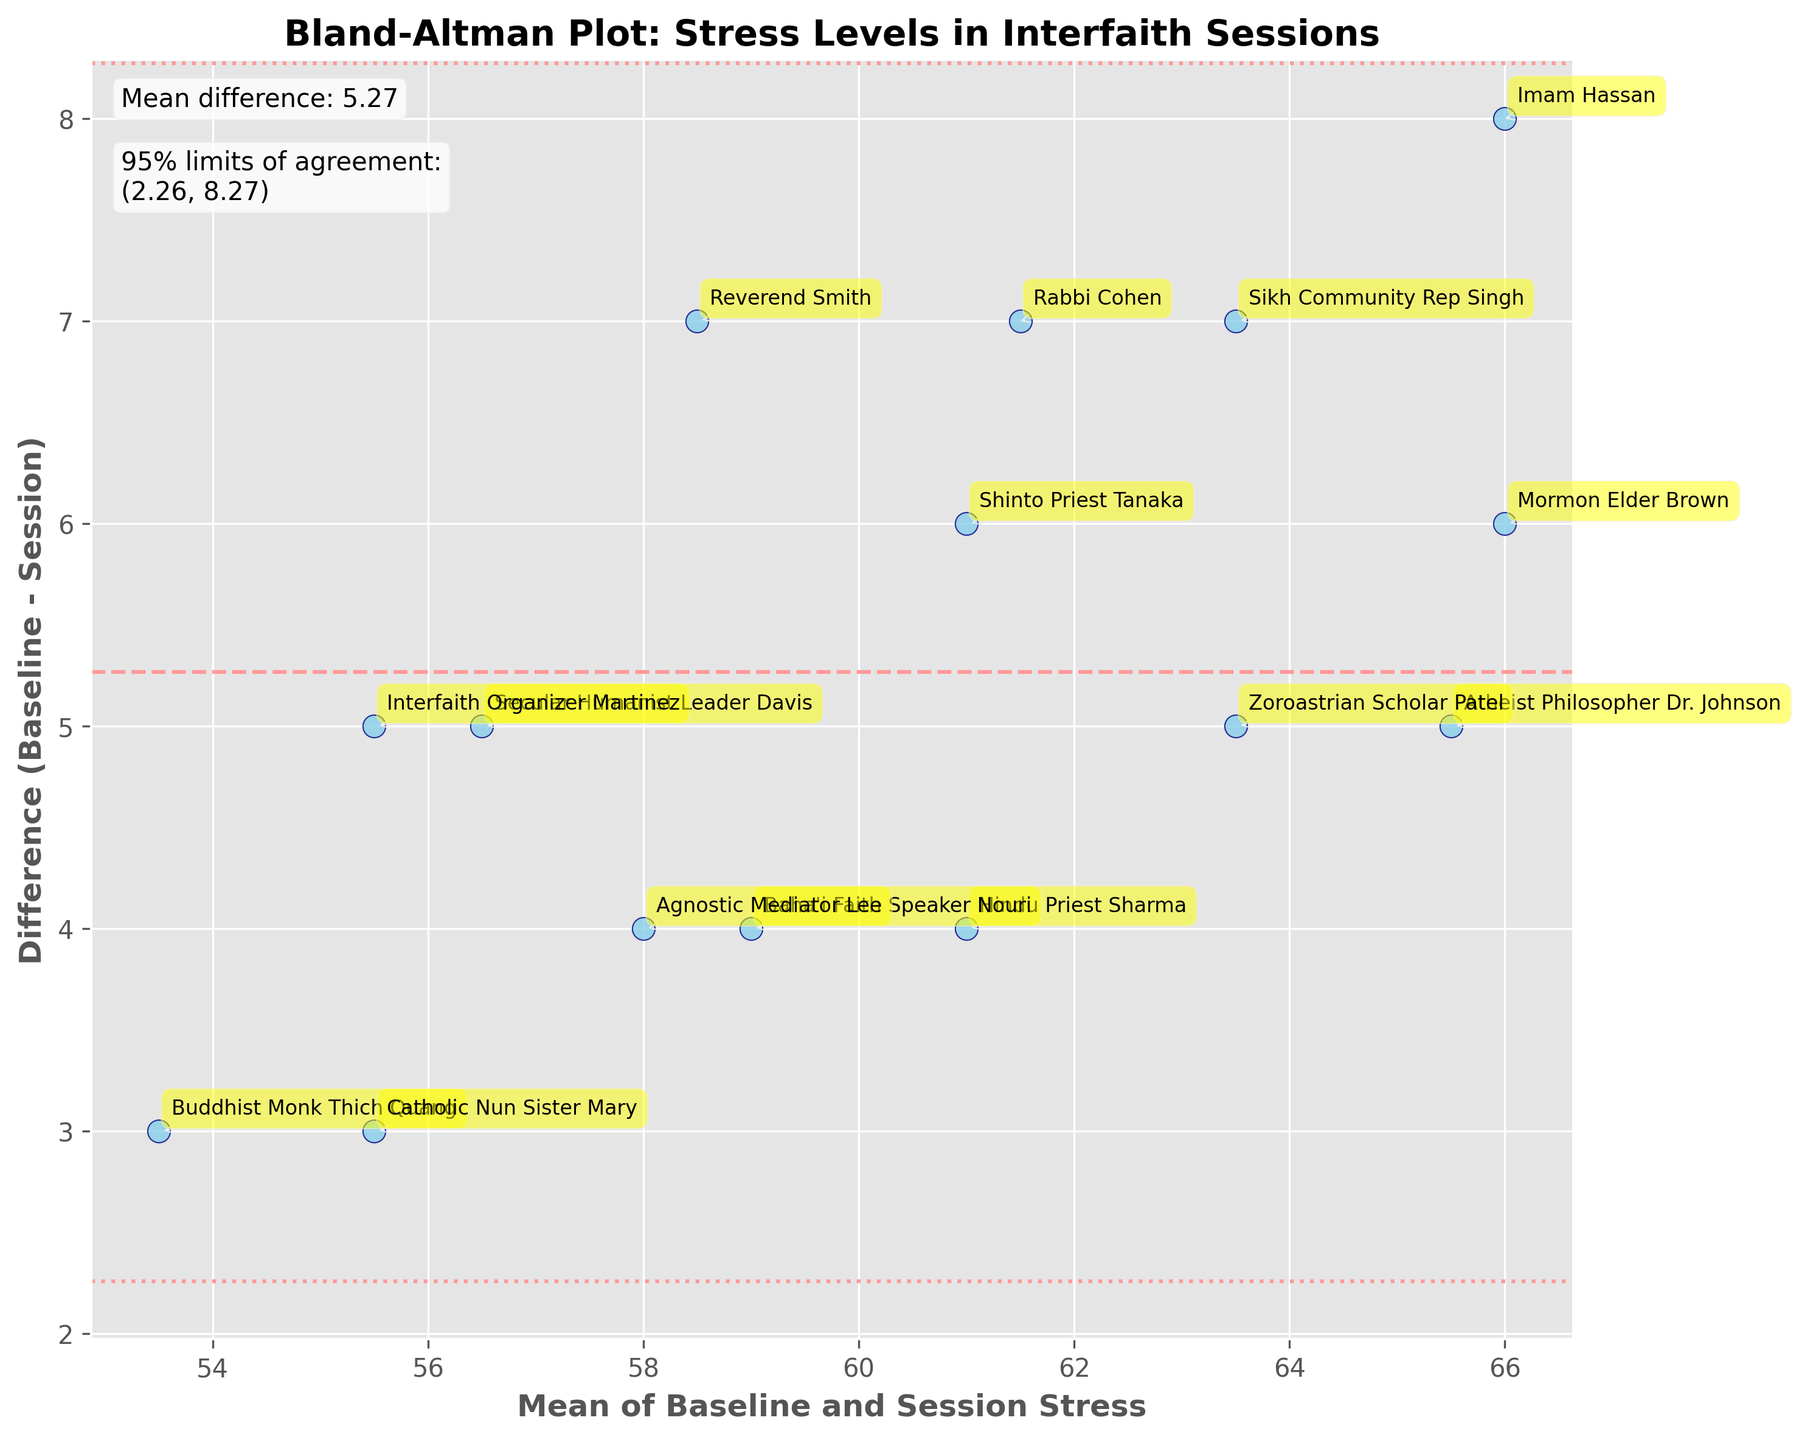What is the title of the plot? The title of the plot is located at the top of the figure. It provides an overview of what the data represents.
Answer: Bland-Altman Plot: Stress Levels in Interfaith Sessions How many data points are represented in the plot? The number of data points can be counted by looking at the scatter plot and counting the individual points.
Answer: 15 What does the x-axis represent? The x-axis in a Bland-Altman plot represents the mean of the baseline and session stress levels for each participant. This is calculated by taking the average of the two stress levels.
Answer: Mean of Baseline and Session Stress What does the y-axis represent? The y-axis in a Bland-Altman plot represents the difference between baseline and session stress levels for each participant. This is calculated by subtracting the session stress level from the baseline stress level.
Answer: Difference (Baseline - Session) Which participant had the largest reduction in stress level? The largest reduction in stress level can be identified by finding the most negative value on the y-axis and looking at which participant is labeled there.
Answer: Reverend Smith What are the values of the 95% limits of agreement? The 95% limits of agreement are shown as horizontal lines on the plot and are also labeled within the figure. They represent the range in which most differences between baseline and session stress levels will lie.
Answer: (-1.85, 11.39) What is the mean difference between baseline and session stress levels? The mean difference is indicated by a horizontal dashed line and labeled in the figure. It represents the average reduction in stress levels across all participants.
Answer: 4.77 Which participant had the smallest change in stress levels? The smallest change in stress levels can be identified by finding the value closest to zero on the y-axis and looking at which participant is labeled there.
Answer: Buddhist Monk Thich Quang Compare stress reduction between Rabbi Cohen and Imam Hassan. To compare, look at their positions on the y-axis and see which one is further down (indicating a larger reduction) or closer to zero (indicating a smaller reduction). Rabbi Cohen has a difference of 7, and Imam Hassan has a difference of 8.
Answer: Imam Hassan had a larger reduction Is there any participant with an increase in stress levels after the session? No points are located above the x-axis on the y-axis which means there are no positive differences between baseline and session stress, indicating that all participants had a reduction in stress.
Answer: No 